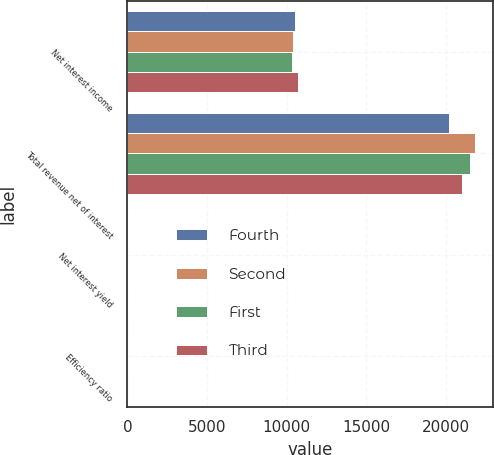Convert chart. <chart><loc_0><loc_0><loc_500><loc_500><stacked_bar_chart><ecel><fcel>Net interest income<fcel>Total revenue net of interest<fcel>Net interest yield<fcel>Efficiency ratio<nl><fcel>Fourth<fcel>10526<fcel>20224<fcel>2.23<fcel>65.08<nl><fcel>Second<fcel>10429<fcel>21863<fcel>2.23<fcel>61.66<nl><fcel>First<fcel>10341<fcel>21509<fcel>2.23<fcel>62.73<nl><fcel>Third<fcel>10700<fcel>21005<fcel>2.33<fcel>70.54<nl></chart> 